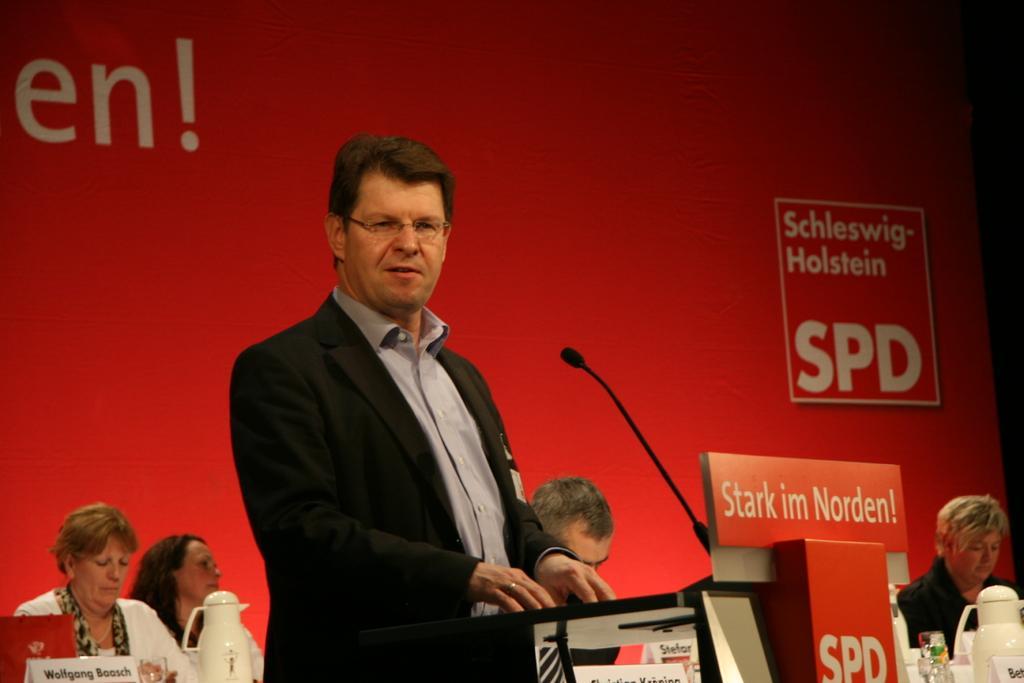Describe this image in one or two sentences. In this picture I can see there is a person standing and there is a wooden standing and in the backdrop there is a red backdrop. 